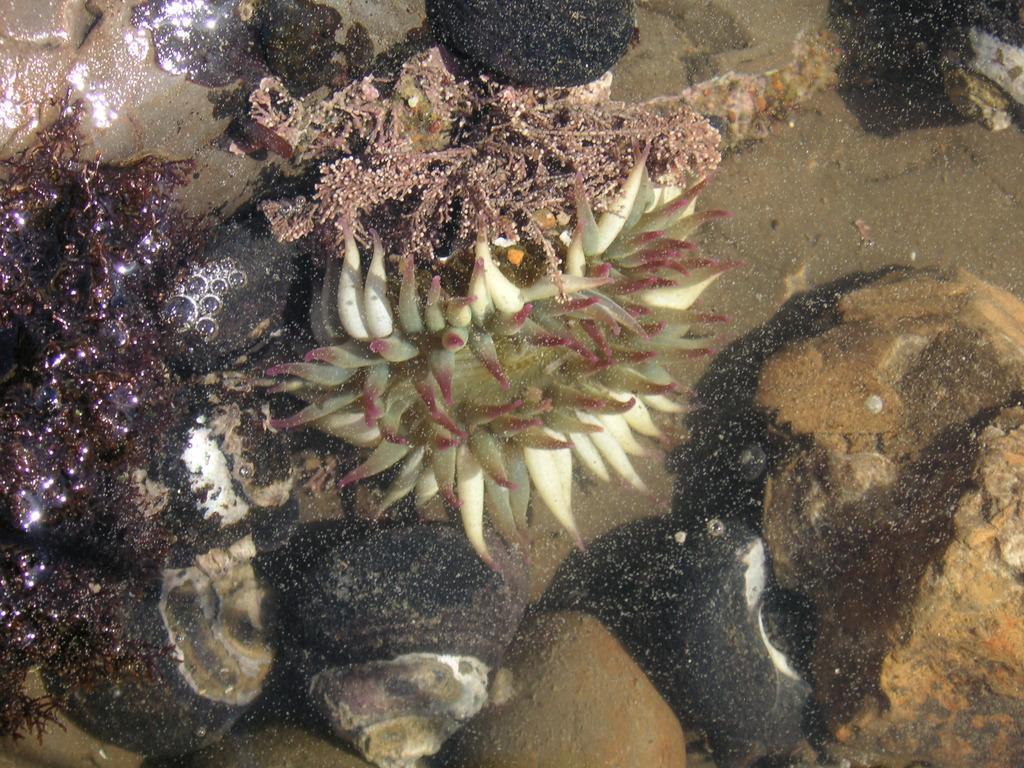How would you summarize this image in a sentence or two? In this image I can see few aquatic plants in different colors. I can see few stones and the water. 